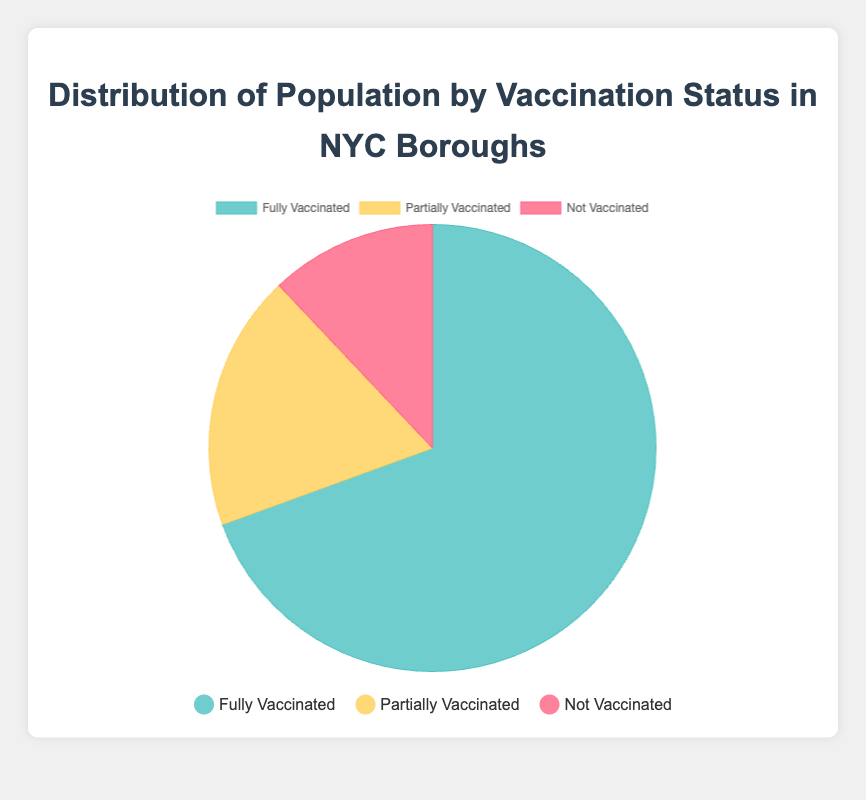What is the percentage of fully vaccinated people in the overall NYC population? First, sum up the total population (fully vaccinated, partially vaccinated, and not vaccinated) in all boroughs: (800,000 + 200,000 + 100,000) + (900,000 + 250,000 + 150,000) + (950,000 + 300,000 + 200,000) + (700,000 + 150,000 + 120,000) + (400,000 + 100,000 + 80,000) = 5,400,000. Then, sum up the fully vaccinated: 800,000 + 900,000 + 950,000 + 700,000 + 400,000 = 3,750,000. Finally, calculate the percentage: (3,750,000 / 5,400,000) * 100 = 69.44%.
Answer: 69.44% Which borough has the highest number of partially vaccinated people? Look at the population for partially vaccinated people in each borough: Manhattan (200,000), Brooklyn (250,000), Queens (300,000), The Bronx (150,000), Staten Island (100,000). Queens has the highest number of partially vaccinated people with 300,000.
Answer: Queens What is the ratio of fully vaccinated to not vaccinated people in Brooklyn? In Brooklyn, there are 900,000 fully vaccinated and 150,000 not vaccinated people. The ratio is 900,000:150,000, which simplifies to 6:1.
Answer: 6:1 Compare the number of fully vaccinated people between Manhattan and The Bronx. Which borough has more? The number of fully vaccinated people in Manhattan is 800,000, and in The Bronx, it is 700,000. Manhattan has more fully vaccinated people.
Answer: Manhattan How many more people are partially vaccinated in Queens compared to Staten Island? The number of partially vaccinated people in Queens is 300,000, and in Staten Island, it is 100,000. The difference is 300,000 - 100,000 = 200,000.
Answer: 200,000 What is the average number of fully vaccinated people per borough? The number of fully vaccinated people is as follows: Manhattan (800,000), Brooklyn (900,000), Queens (950,000), The Bronx (700,000), Staten Island (400,000). The average is (800,000 + 900,000 + 950,000 + 700,000 + 400,000) / 5 = 3,750,000 / 5 = 750,000.
Answer: 750,000 If you combine the populations of Partially Vaccinated and Not Vaccinated people, which borough has the highest combined number? Sum the partially vaccinated and not vaccinated numbers for each borough: Manhattan (200,000 + 100,000 = 300,000), Brooklyn (250,000 + 150,000 = 400,000), Queens (300,000 + 200,000 = 500,000), The Bronx (150,000 + 120,000 = 270,000), Staten Island (100,000 + 80,000 = 180,000). Queens has the highest combined number with 500,000.
Answer: Queens 